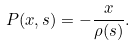Convert formula to latex. <formula><loc_0><loc_0><loc_500><loc_500>P ( x , s ) = - { \frac { x } { \rho ( s ) } } .</formula> 